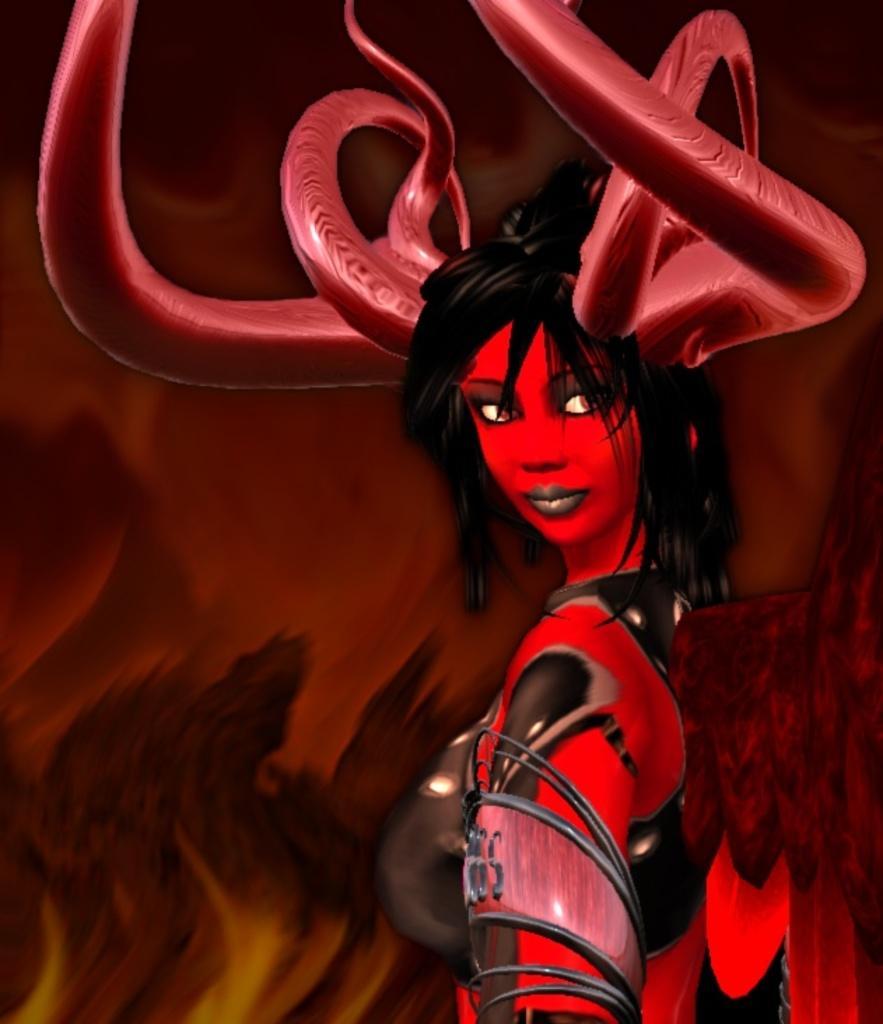Please provide a concise description of this image. This is an animated image in which we can see a person in red color is having horns on the head. The background of the image is in brown color. 